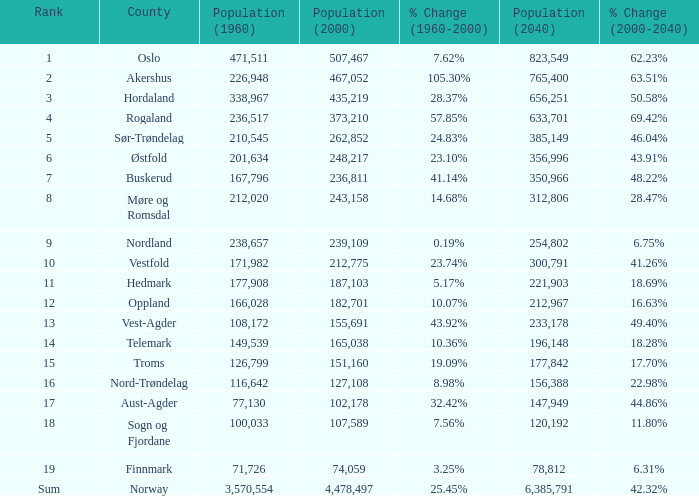What was the population of a county in 1960 that had a population of 467,052 in 2000 and 78,812 in 2040? None. 